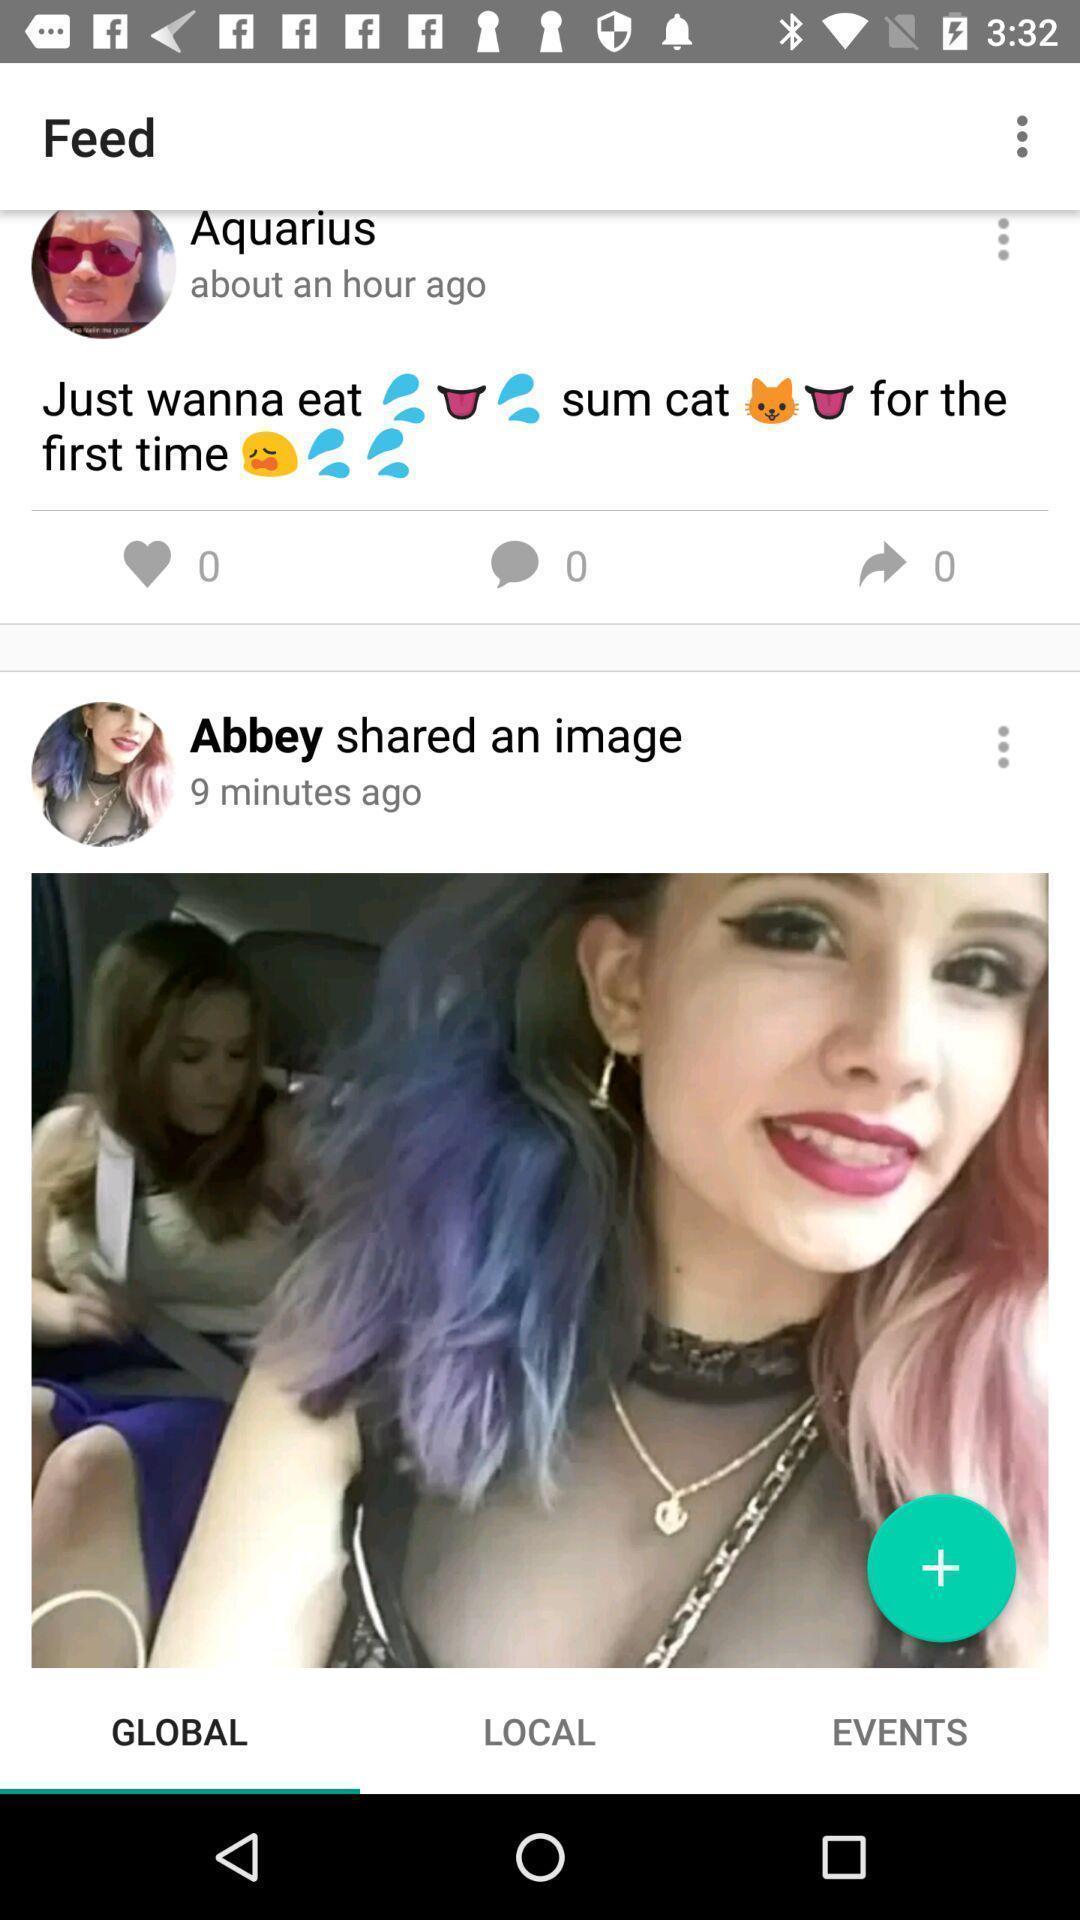Tell me about the visual elements in this screen capture. Various feed displayed for lgbtq social media app. 